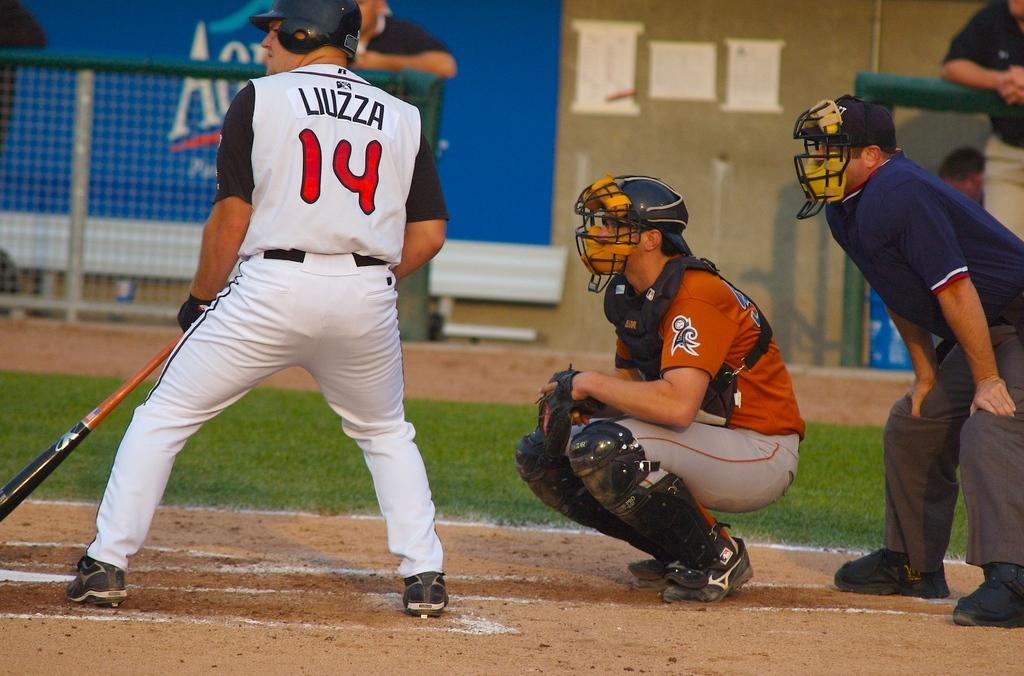<image>
Provide a brief description of the given image. A baseball player with the number 14 on his shirt. 